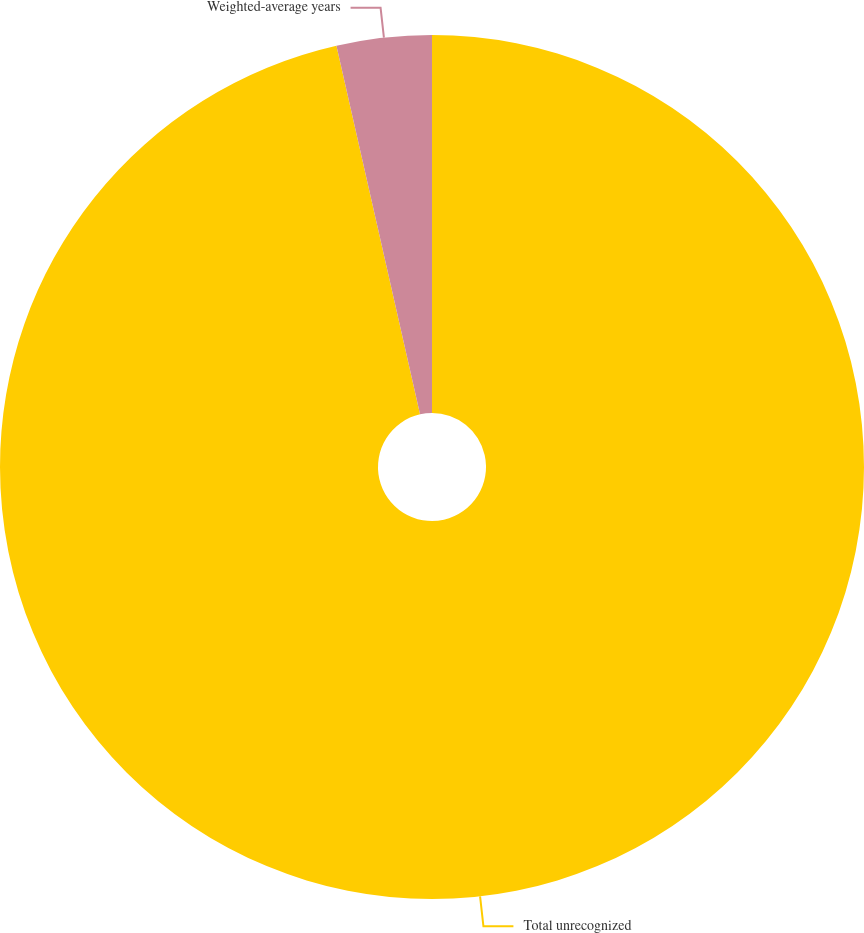<chart> <loc_0><loc_0><loc_500><loc_500><pie_chart><fcel>Total unrecognized<fcel>Weighted-average years<nl><fcel>96.45%<fcel>3.55%<nl></chart> 